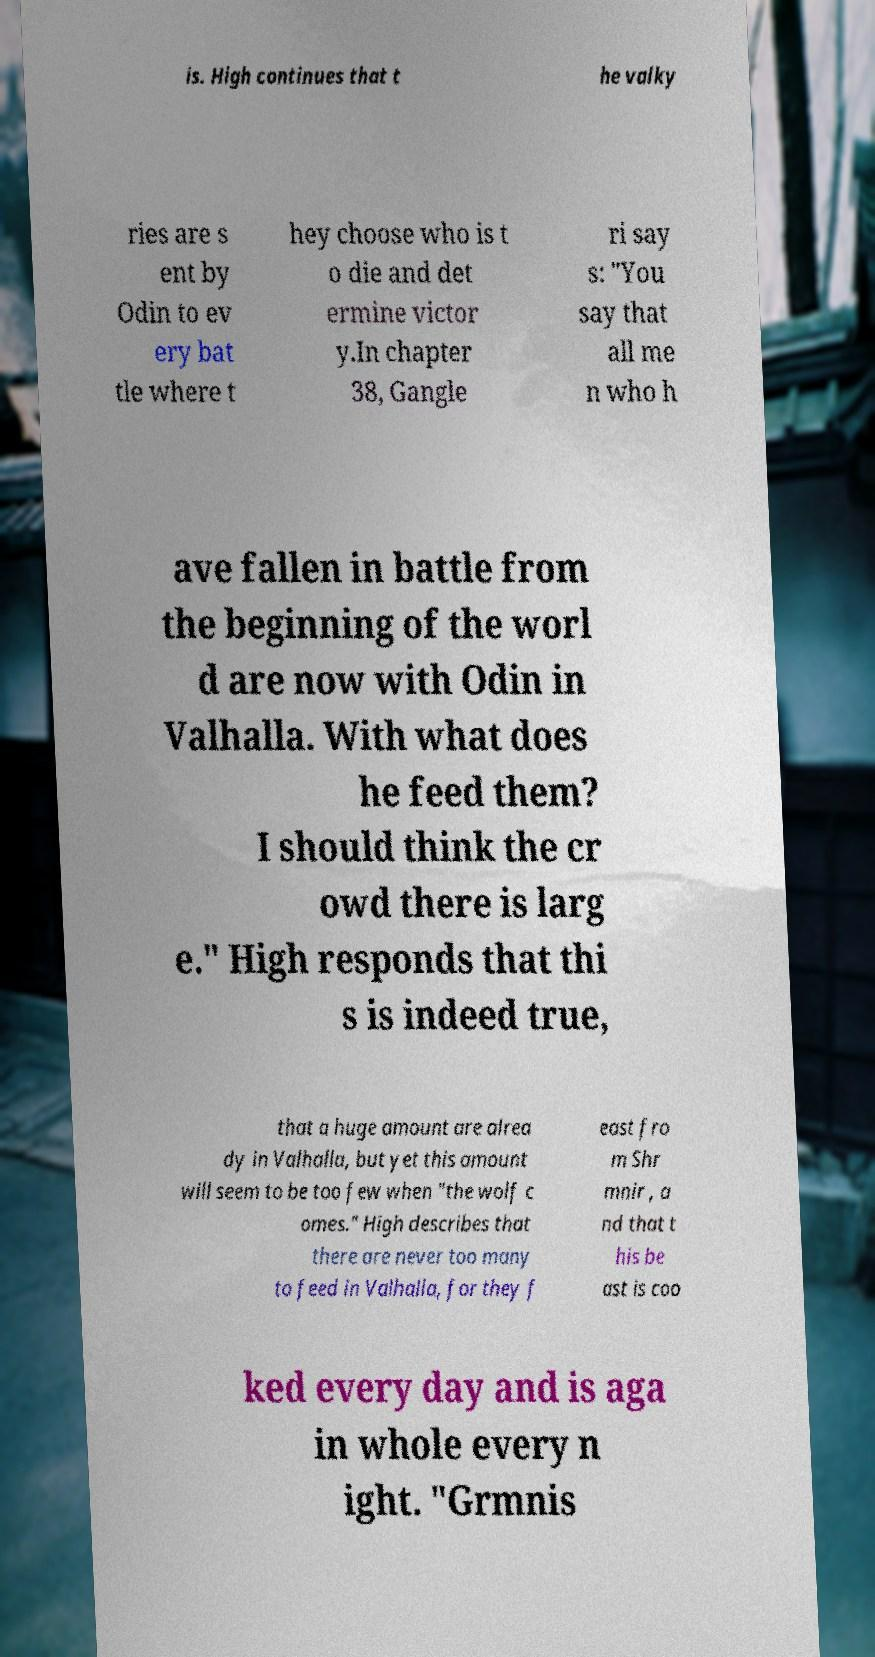For documentation purposes, I need the text within this image transcribed. Could you provide that? is. High continues that t he valky ries are s ent by Odin to ev ery bat tle where t hey choose who is t o die and det ermine victor y.In chapter 38, Gangle ri say s: "You say that all me n who h ave fallen in battle from the beginning of the worl d are now with Odin in Valhalla. With what does he feed them? I should think the cr owd there is larg e." High responds that thi s is indeed true, that a huge amount are alrea dy in Valhalla, but yet this amount will seem to be too few when "the wolf c omes." High describes that there are never too many to feed in Valhalla, for they f east fro m Shr mnir , a nd that t his be ast is coo ked every day and is aga in whole every n ight. "Grmnis 